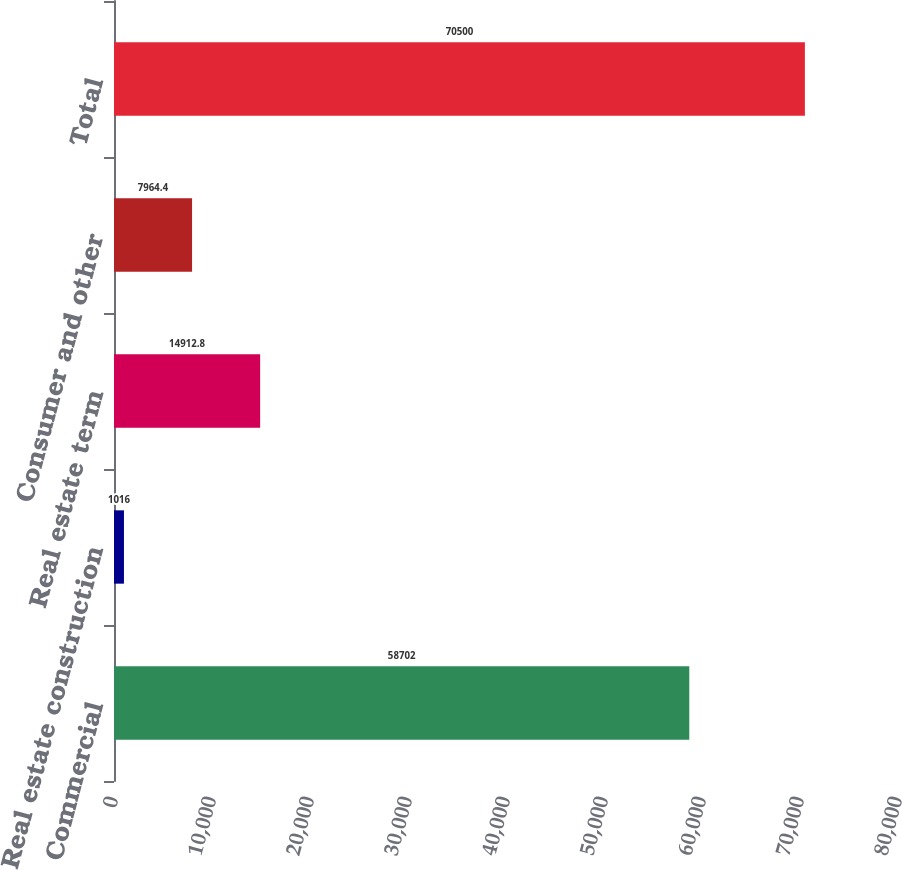Convert chart to OTSL. <chart><loc_0><loc_0><loc_500><loc_500><bar_chart><fcel>Commercial<fcel>Real estate construction<fcel>Real estate term<fcel>Consumer and other<fcel>Total<nl><fcel>58702<fcel>1016<fcel>14912.8<fcel>7964.4<fcel>70500<nl></chart> 